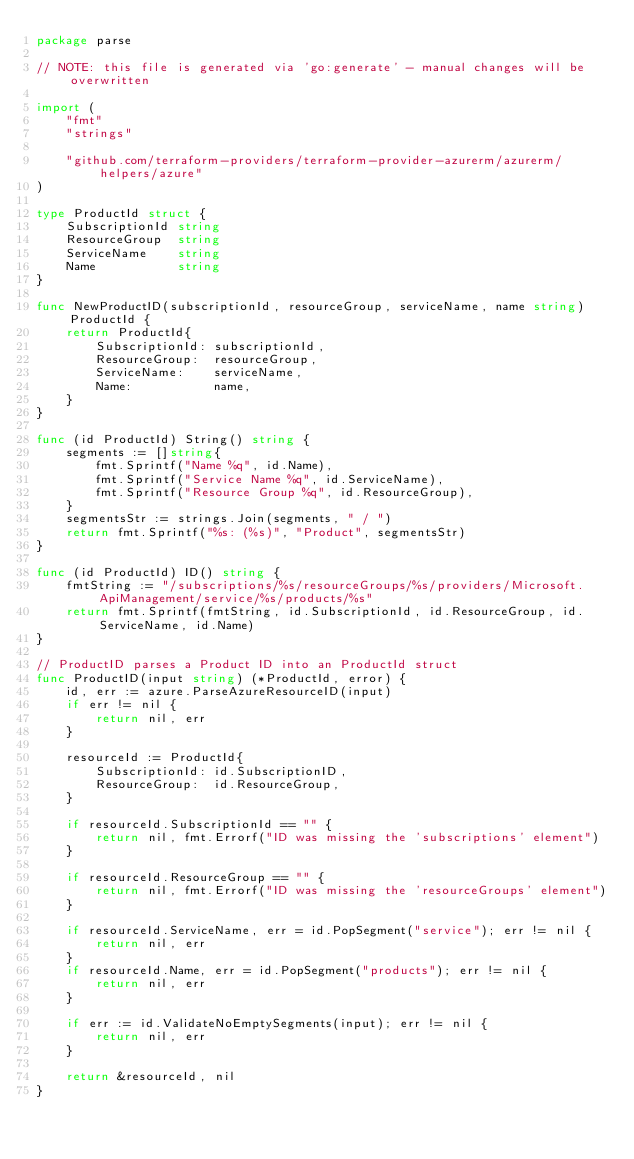Convert code to text. <code><loc_0><loc_0><loc_500><loc_500><_Go_>package parse

// NOTE: this file is generated via 'go:generate' - manual changes will be overwritten

import (
	"fmt"
	"strings"

	"github.com/terraform-providers/terraform-provider-azurerm/azurerm/helpers/azure"
)

type ProductId struct {
	SubscriptionId string
	ResourceGroup  string
	ServiceName    string
	Name           string
}

func NewProductID(subscriptionId, resourceGroup, serviceName, name string) ProductId {
	return ProductId{
		SubscriptionId: subscriptionId,
		ResourceGroup:  resourceGroup,
		ServiceName:    serviceName,
		Name:           name,
	}
}

func (id ProductId) String() string {
	segments := []string{
		fmt.Sprintf("Name %q", id.Name),
		fmt.Sprintf("Service Name %q", id.ServiceName),
		fmt.Sprintf("Resource Group %q", id.ResourceGroup),
	}
	segmentsStr := strings.Join(segments, " / ")
	return fmt.Sprintf("%s: (%s)", "Product", segmentsStr)
}

func (id ProductId) ID() string {
	fmtString := "/subscriptions/%s/resourceGroups/%s/providers/Microsoft.ApiManagement/service/%s/products/%s"
	return fmt.Sprintf(fmtString, id.SubscriptionId, id.ResourceGroup, id.ServiceName, id.Name)
}

// ProductID parses a Product ID into an ProductId struct
func ProductID(input string) (*ProductId, error) {
	id, err := azure.ParseAzureResourceID(input)
	if err != nil {
		return nil, err
	}

	resourceId := ProductId{
		SubscriptionId: id.SubscriptionID,
		ResourceGroup:  id.ResourceGroup,
	}

	if resourceId.SubscriptionId == "" {
		return nil, fmt.Errorf("ID was missing the 'subscriptions' element")
	}

	if resourceId.ResourceGroup == "" {
		return nil, fmt.Errorf("ID was missing the 'resourceGroups' element")
	}

	if resourceId.ServiceName, err = id.PopSegment("service"); err != nil {
		return nil, err
	}
	if resourceId.Name, err = id.PopSegment("products"); err != nil {
		return nil, err
	}

	if err := id.ValidateNoEmptySegments(input); err != nil {
		return nil, err
	}

	return &resourceId, nil
}
</code> 